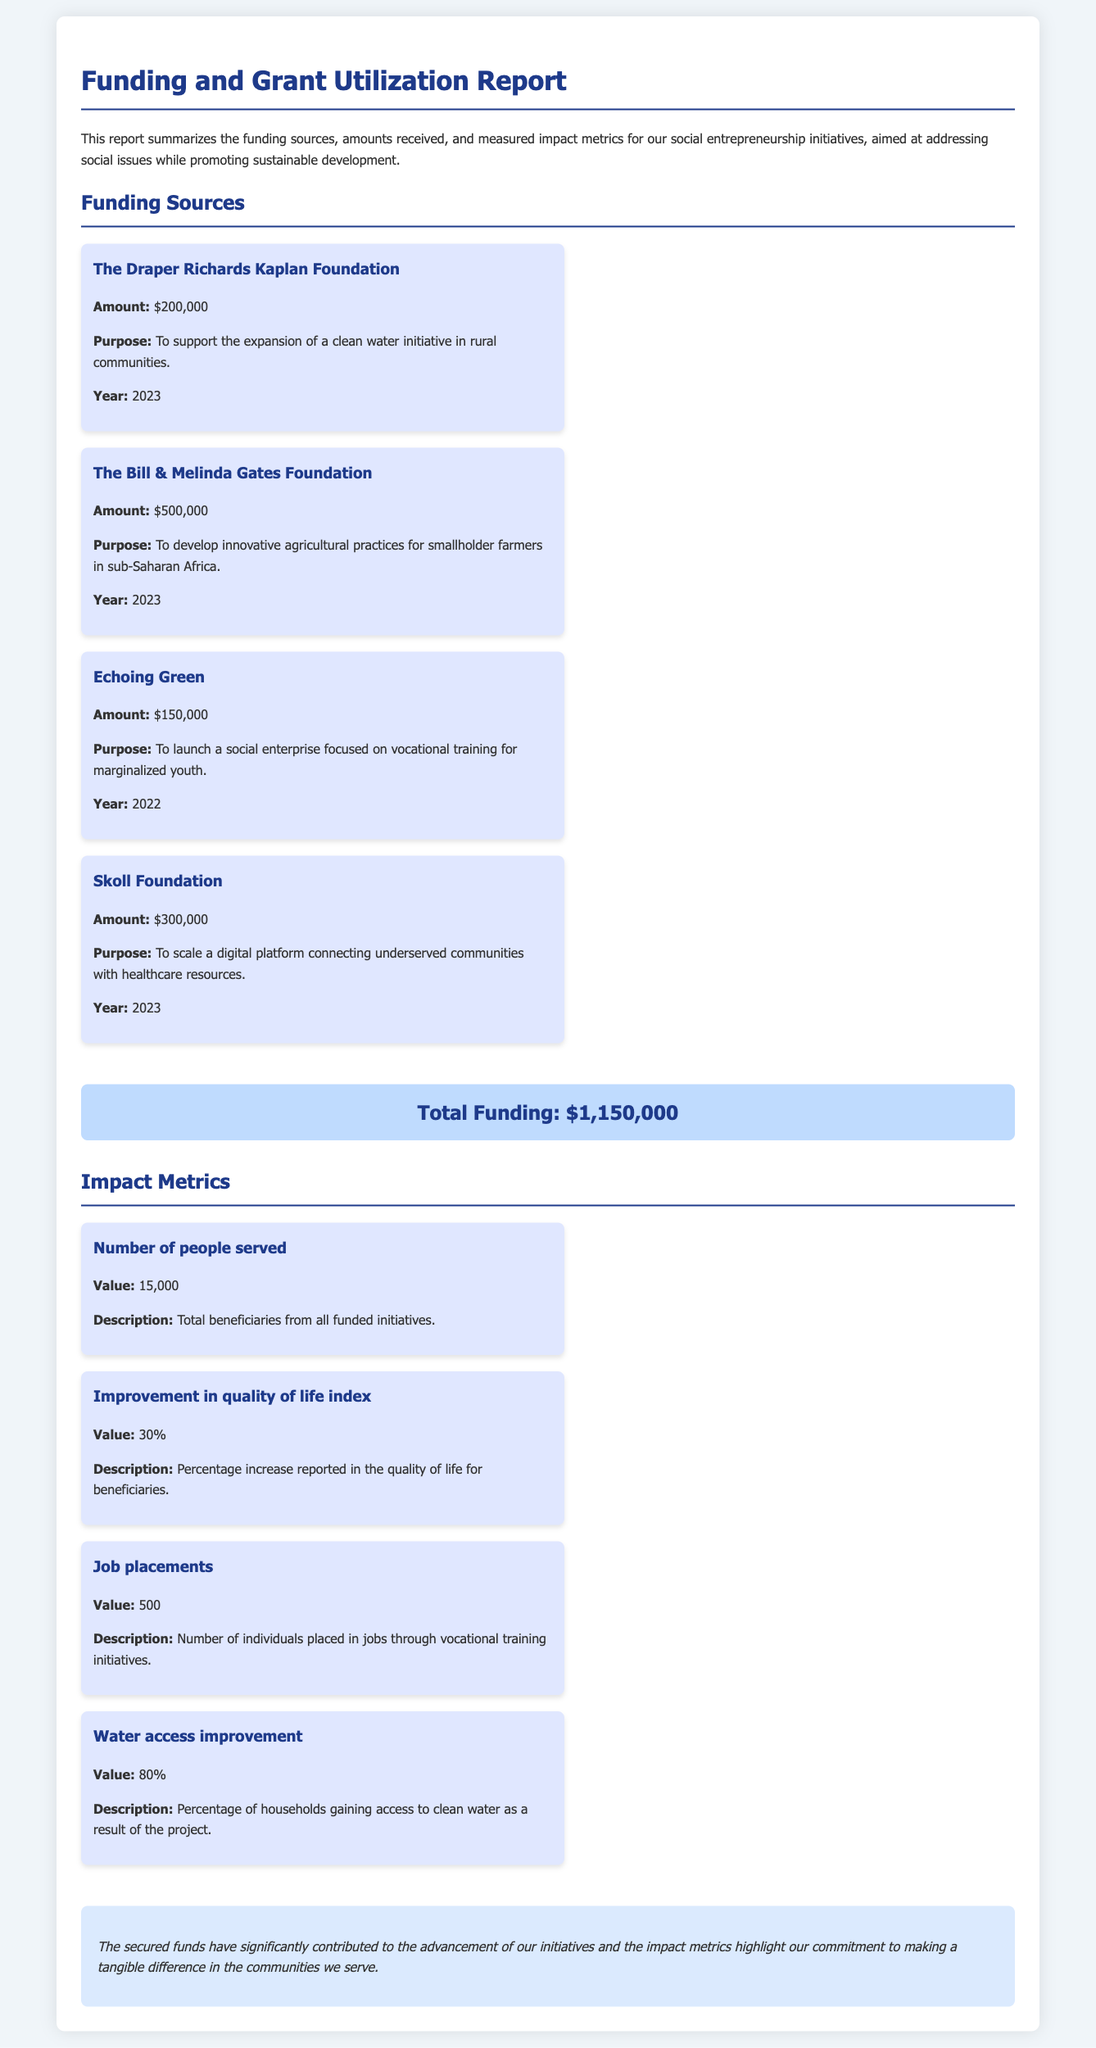What is the total funding? The total funding is explicitly mentioned in the report, totaling all funding sources together.
Answer: $1,150,000 Who provided funding for the clean water initiative? The source of funding for the clean water initiative is specified in the report.
Answer: The Draper Richards Kaplan Foundation What was the amount received from the Bill & Melinda Gates Foundation? The amount from the Bill & Melinda Gates Foundation is stated directly in the funding sources section.
Answer: $500,000 How many job placements were achieved through vocational training initiatives? The document lists the number of job placements as one of the impact metrics.
Answer: 500 What percentage of households gained access to clean water as a result of the project? The document provides this metric as part of the impact metrics section.
Answer: 80% What is the purpose of the grant from Echoing Green? The report outlines the specific purpose for which the funding from Echoing Green was obtained.
Answer: To launch a social enterprise focused on vocational training for marginalized youth Which foundation supported the scaling of a digital healthcare platform? The document specifies the foundation supporting this particular initiative.
Answer: Skoll Foundation What is the improvement in the quality of life index percentage? The percentage improvement in the quality of life index is detailed in the impact metrics.
Answer: 30% 